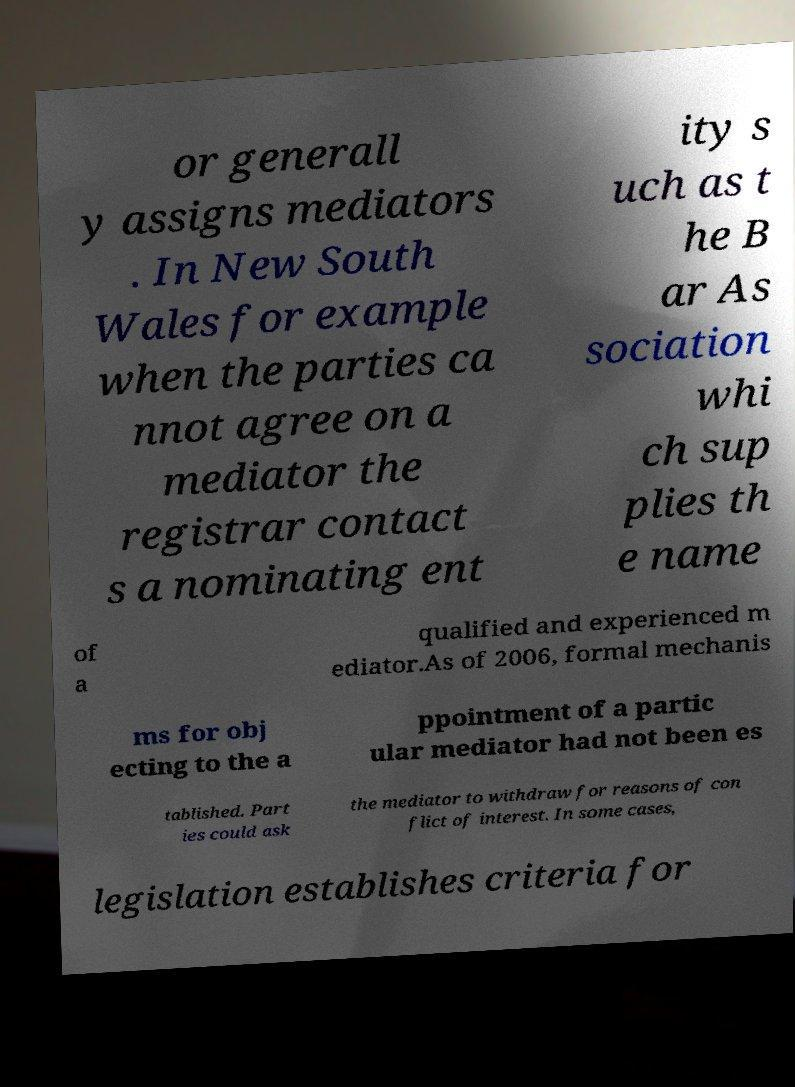Could you assist in decoding the text presented in this image and type it out clearly? or generall y assigns mediators . In New South Wales for example when the parties ca nnot agree on a mediator the registrar contact s a nominating ent ity s uch as t he B ar As sociation whi ch sup plies th e name of a qualified and experienced m ediator.As of 2006, formal mechanis ms for obj ecting to the a ppointment of a partic ular mediator had not been es tablished. Part ies could ask the mediator to withdraw for reasons of con flict of interest. In some cases, legislation establishes criteria for 